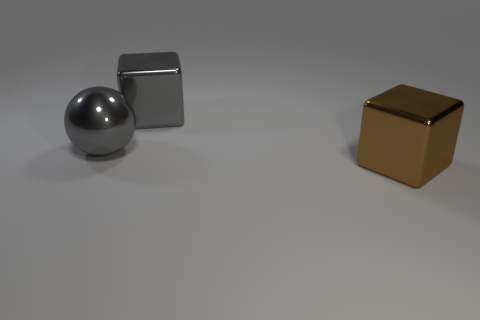Is the shape of the large gray metallic object on the left side of the large gray metal cube the same as  the large brown metal thing?
Provide a succinct answer. No. There is a brown object that is the same size as the gray metal block; what is its material?
Offer a very short reply. Metal. Are there the same number of big metallic cubes to the left of the large gray metal cube and big blocks that are behind the big gray sphere?
Offer a very short reply. No. How many big gray metallic objects are behind the big metal object right of the metallic cube that is behind the big brown shiny cube?
Keep it short and to the point. 2. There is a ball; is it the same color as the metallic block on the left side of the big brown cube?
Provide a short and direct response. Yes. What size is the ball that is made of the same material as the big brown cube?
Provide a succinct answer. Large. Are there more large blocks that are behind the large brown cube than brown cubes?
Provide a succinct answer. No. There is a large cube to the left of the big metal block that is in front of the large shiny block that is left of the brown block; what is its material?
Ensure brevity in your answer.  Metal. Is the material of the sphere the same as the block that is on the left side of the brown metallic cube?
Give a very brief answer. Yes. What is the material of the large gray object that is the same shape as the brown shiny thing?
Offer a terse response. Metal. 